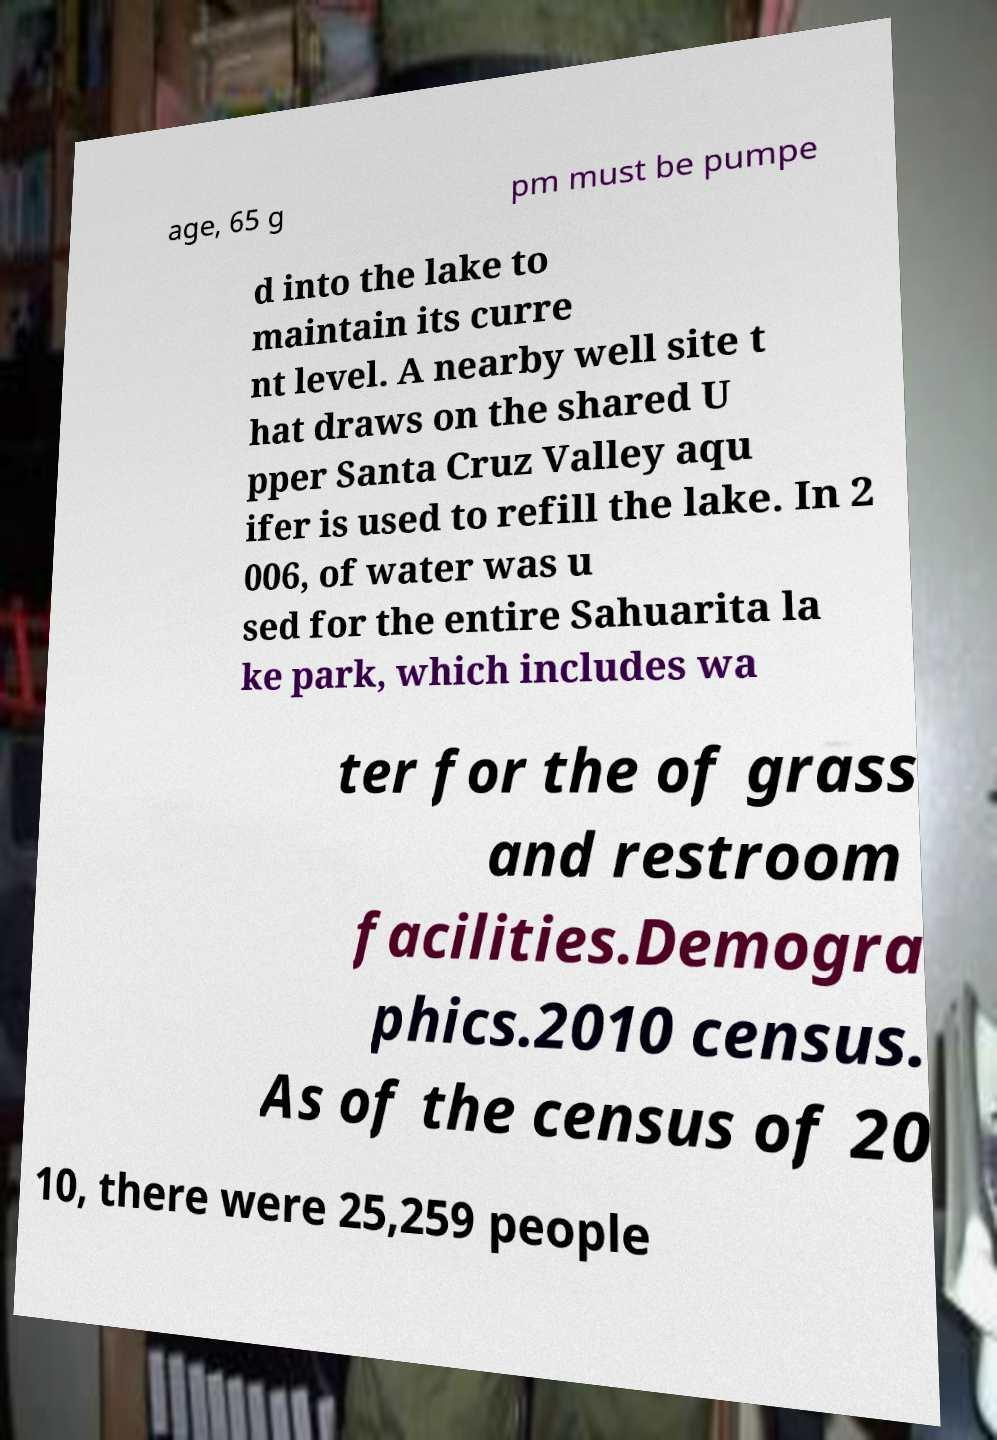Can you read and provide the text displayed in the image?This photo seems to have some interesting text. Can you extract and type it out for me? age, 65 g pm must be pumpe d into the lake to maintain its curre nt level. A nearby well site t hat draws on the shared U pper Santa Cruz Valley aqu ifer is used to refill the lake. In 2 006, of water was u sed for the entire Sahuarita la ke park, which includes wa ter for the of grass and restroom facilities.Demogra phics.2010 census. As of the census of 20 10, there were 25,259 people 